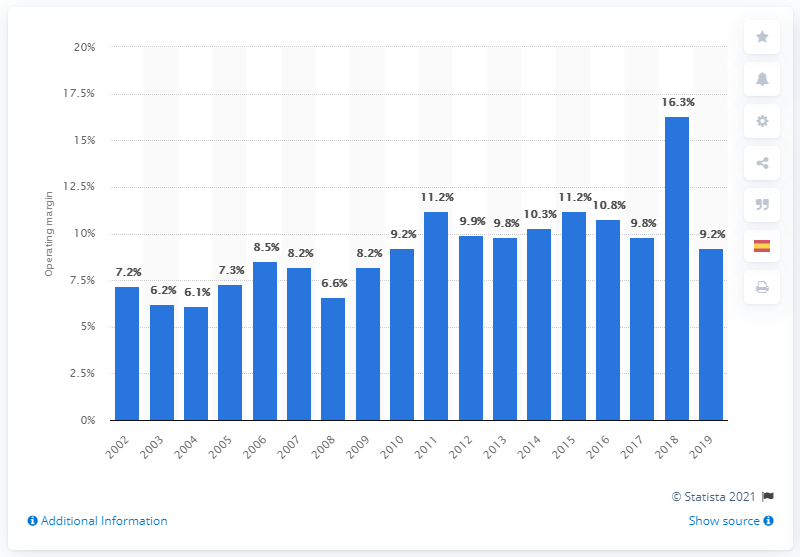Give some essential details in this illustration. In 2002, the operating margin of the U.S. chemical industry was 7.2%. In 2019, the operating margin of the U.S. chemical industry was 9.2%. 